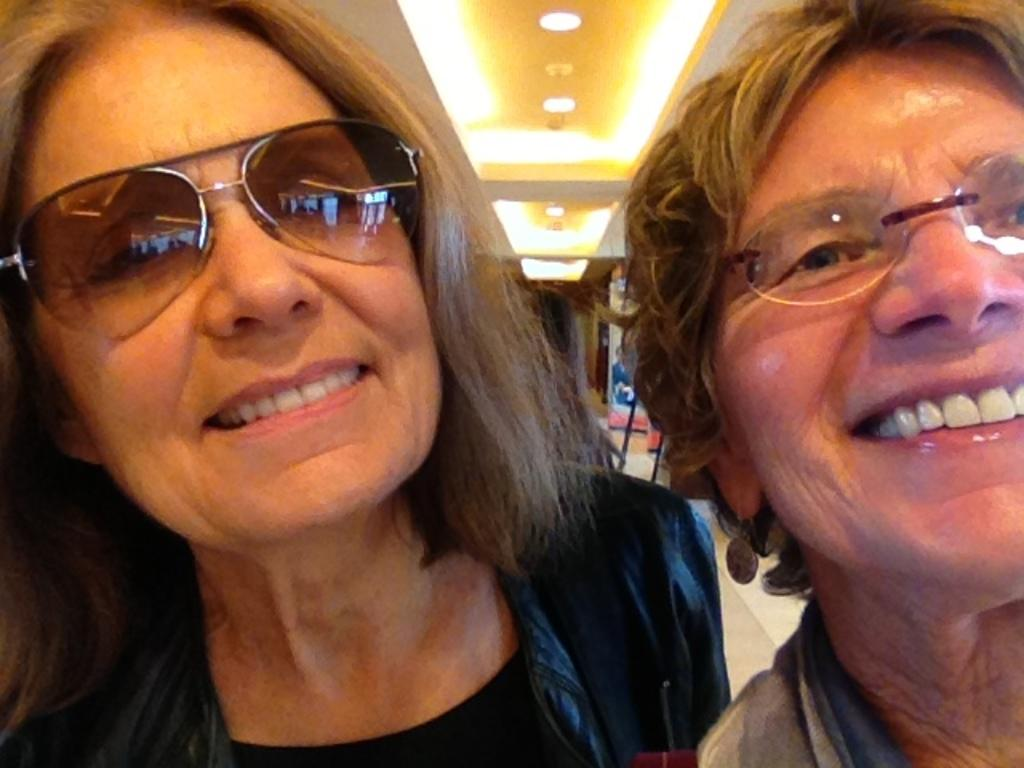How many people are present in the image? There are two people in the image. What are the people wearing? The people are wearing dresses. What can be seen in the background of the image? There is a door visible in the background of the image. What type of lighting is present in the image? There are lights at the top in the image. Can you tell me where the trail starts in the image? There is no trail present in the image. What type of oven is being used by the mom in the image? There is no oven or mom present in the image. 